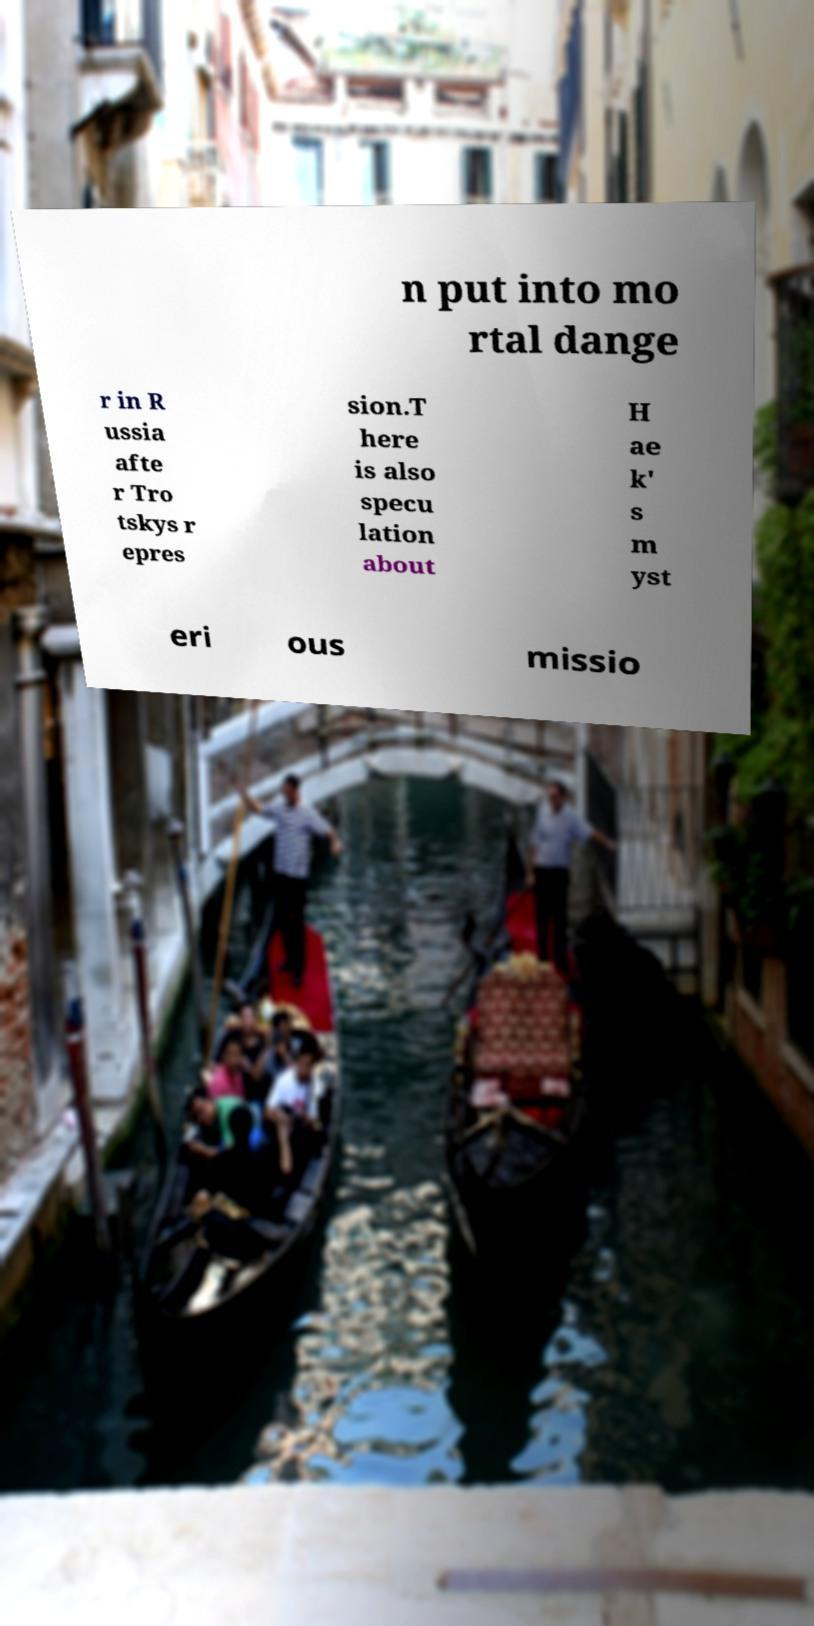Please read and relay the text visible in this image. What does it say? n put into mo rtal dange r in R ussia afte r Tro tskys r epres sion.T here is also specu lation about H ae k' s m yst eri ous missio 